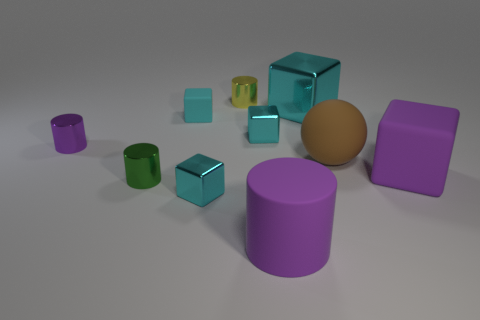Subtract all cyan cubes. How many were subtracted if there are1cyan cubes left? 3 Subtract all small cylinders. How many cylinders are left? 1 Subtract all yellow cylinders. How many cylinders are left? 3 Subtract 0 red cylinders. How many objects are left? 10 Subtract all spheres. How many objects are left? 9 Subtract 1 spheres. How many spheres are left? 0 Subtract all green cubes. Subtract all cyan cylinders. How many cubes are left? 5 Subtract all green balls. How many blue cubes are left? 0 Subtract all large cyan rubber things. Subtract all cyan cubes. How many objects are left? 6 Add 1 cyan rubber cubes. How many cyan rubber cubes are left? 2 